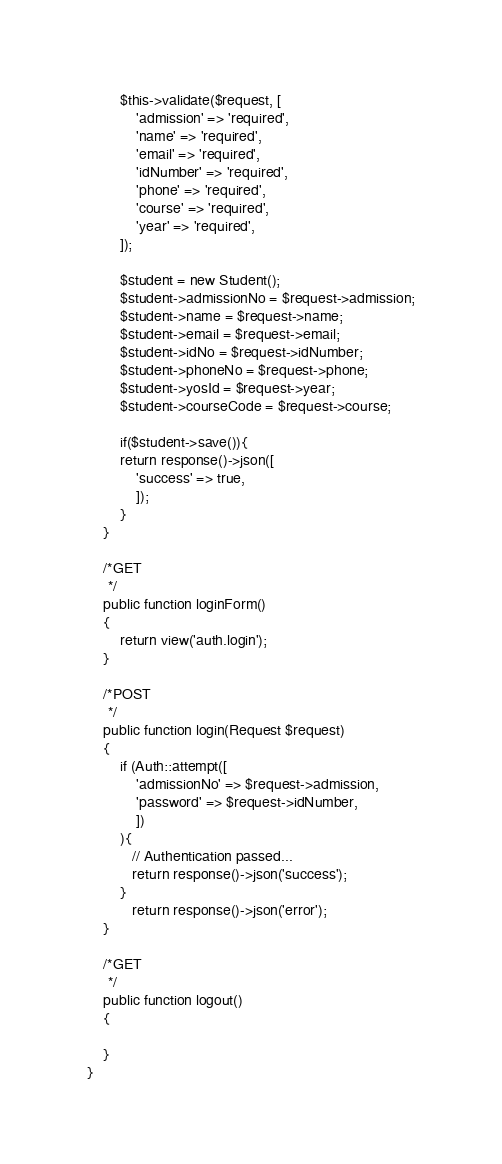<code> <loc_0><loc_0><loc_500><loc_500><_PHP_>        $this->validate($request, [
            'admission' => 'required',
            'name' => 'required',
            'email' => 'required',
            'idNumber' => 'required',
            'phone' => 'required',
            'course' => 'required',
            'year' => 'required',
        ]);

        $student = new Student();
        $student->admissionNo = $request->admission;
        $student->name = $request->name;
        $student->email = $request->email;
        $student->idNo = $request->idNumber;
        $student->phoneNo = $request->phone;
        $student->yosId = $request->year;
        $student->courseCode = $request->course;

        if($student->save()){
        return response()->json([
            'success' => true,
            ]);
        }
    }
    
    /*GET
     */
    public function loginForm()
    {
        return view('auth.login');
    }

    /*POST
     */
    public function login(Request $request)
    {      
        if (Auth::attempt([
            'admissionNo' => $request->admission,
            'password' => $request->idNumber,
            ])
        ){
           // Authentication passed...
           return response()->json('success');
        }
           return response()->json('error');
    }

    /*GET
     */
    public function logout()
    {

    }
}
</code> 